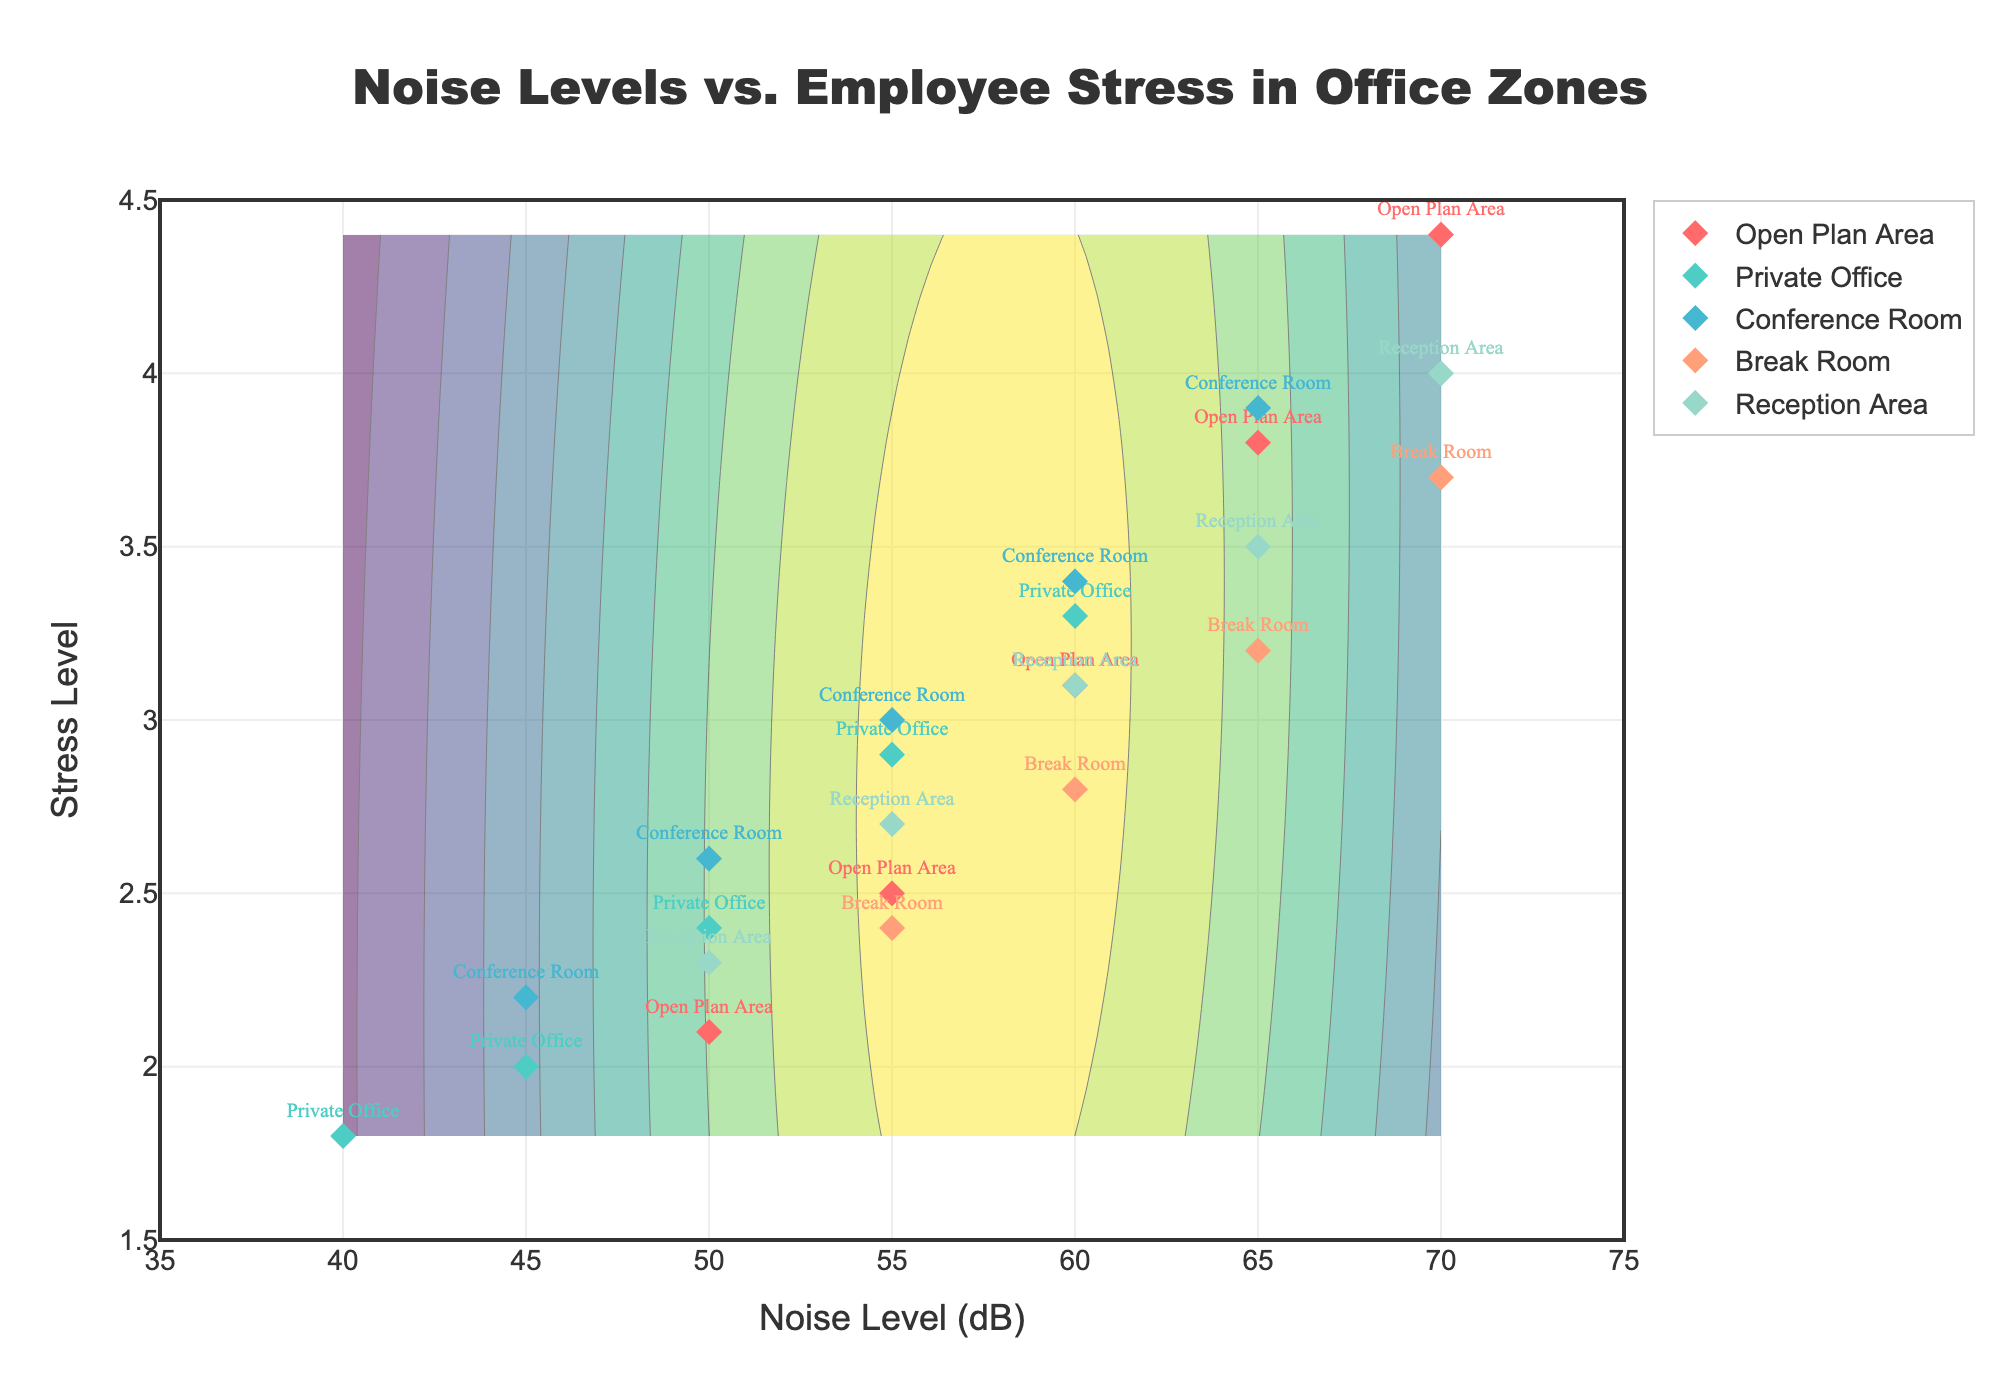How many different office zones are represented in the plot? Count the unique labels in the figure, which are represented by different colors and markers such as "Open Plan Area", "Private Office", "Conference Room", "Break Room", and "Reception Area".
Answer: 5 What are the ranges of the x-axis and y-axis in the plot? The x-axis represents the noise levels in dB, ranging from 35 to 75. The y-axis represents the stress level, ranging from 1.5 to 4.5.
Answer: x: 35-75, y: 1.5-4.5 Which office zone has the highest stress level according to the plot? Locate the highest point on the y-axis for each zone. "Open Plan Area" reaches the highest stress level with a value of 4.4.
Answer: Open Plan Area In which noise level range does the "Private Office" zone lie? Look for the marker labels of "Private Office". They are within the 40 to 60 dB noise level range.
Answer: 40-60 dB What is the average stress level for the "Conference Room" zone? The stress levels for the Conference Room are 2.2, 2.6, 3.0, 3.4, 3.9. Sum them up and divide by the number of points: (2.2 + 2.6 + 3.0 + 3.4 + 3.9) / 5 = 15.1 / 5.
Answer: 3.02 Which office zone shows the lowest stress level at its lowest observed noise level? Compare the lowest stress levels at the lowest noise level data point for each zone: "Private Office" (40 dB, 1.8 stress level) has the lowest observed values.
Answer: Private Office Does the "Break Room" have higher or lower stress levels compared to the "Conference Room" at 60 dB? Compare the stress levels at 60 dB for both zones: Break Room (2.8) vs. Conference Room (3.4). "Break Room" has lower stress levels than "Conference Room" at 60 dB.
Answer: Lower Which zone has the most stable stress levels across varying noise levels? Compare the trend of stress levels relative to noise level increases for each zone. "Private Office" shows a relatively gradual increase, indicating more stability.
Answer: Private Office Between which two noise levels does the "Open Plan Area" show a rapid increase in stress level? Observe the points for "Open Plan Area"; there's a rapid increase between 55 dB (2.5) and 65 dB (3.8).
Answer: 55 dB and 65 dB What is the primary color used for the "Reception Area" zone markers? Identify the color used for "Reception Area" markers; it is indicated by a consistent color scheme, which is light orange.
Answer: Light Orange 